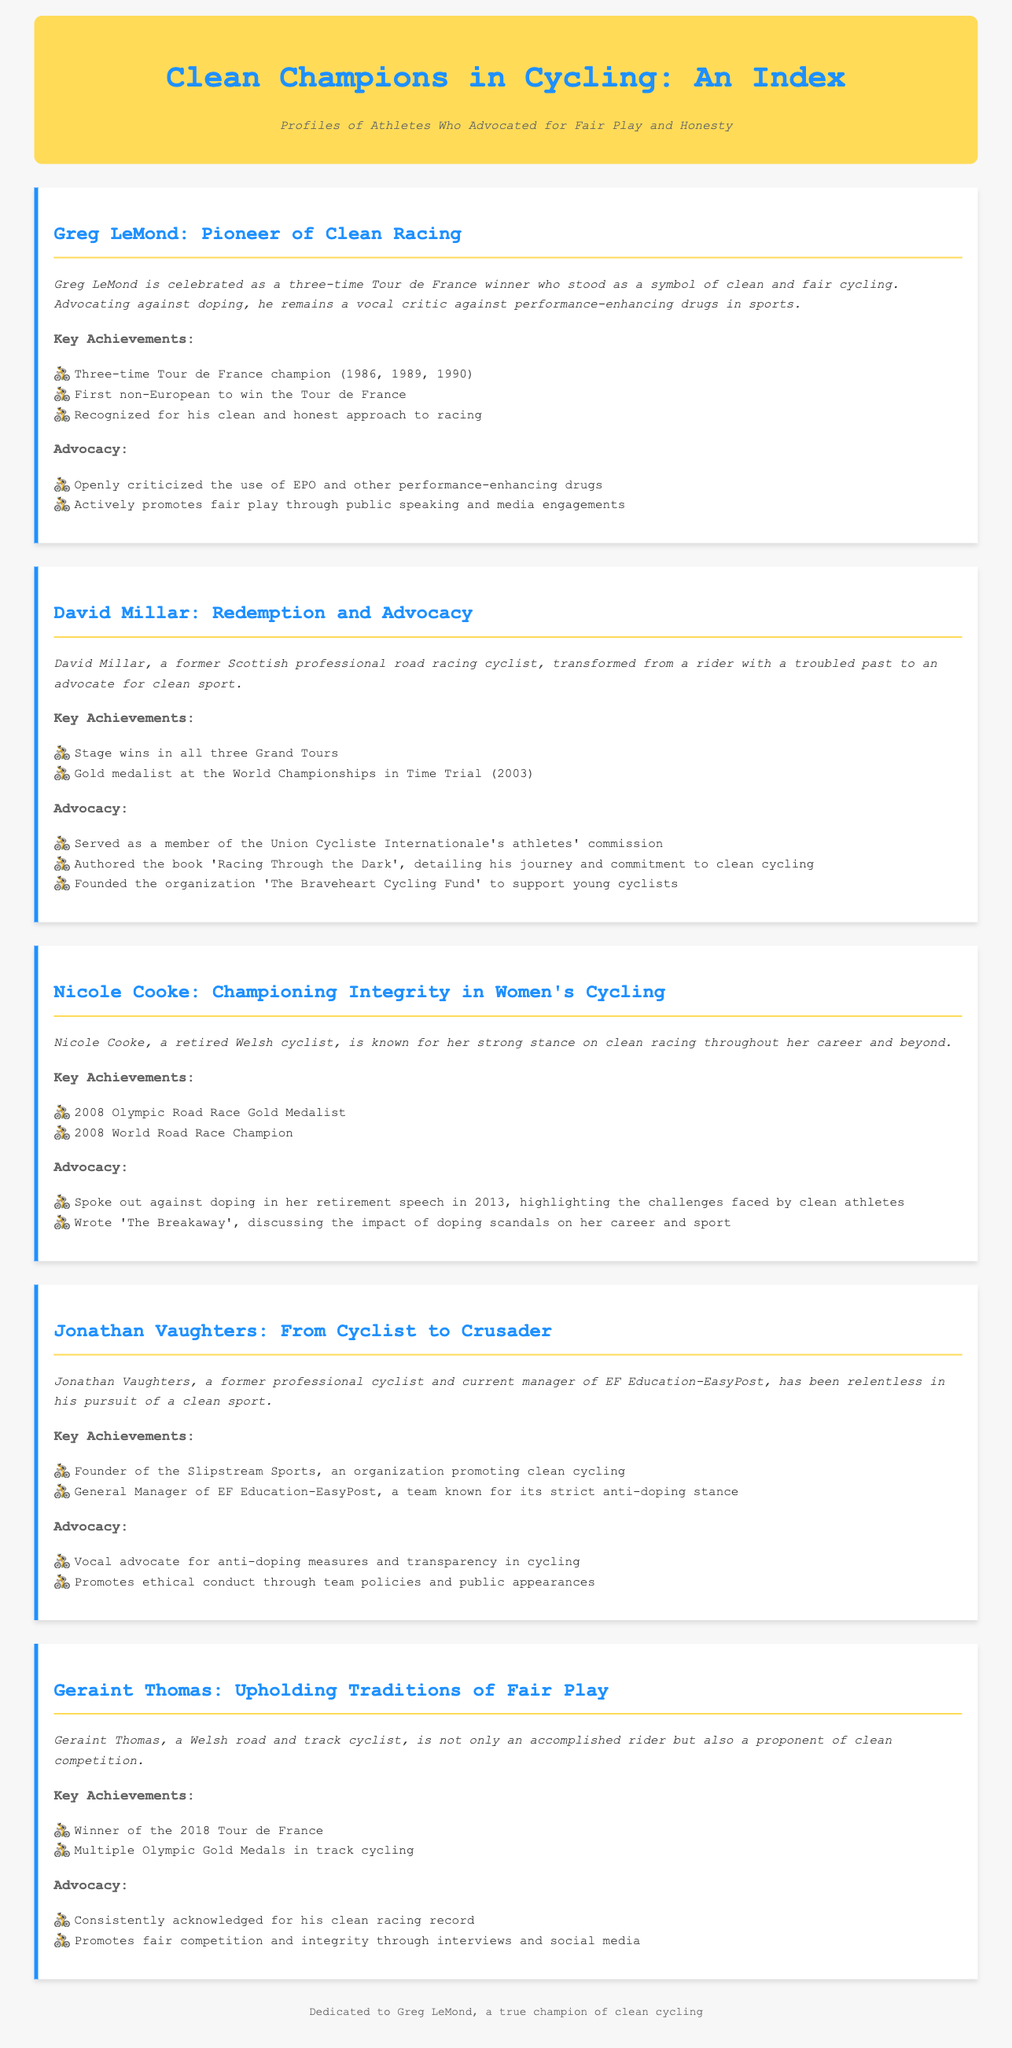What year did Greg LeMond win his first Tour de France? The document states that Greg LeMond won his first Tour de France in 1986.
Answer: 1986 How many Olympic Gold Medals has Geraint Thomas won? According to the document, Geraint Thomas has won multiple Olympic Gold Medals in track cycling.
Answer: Multiple What is the title of the book authored by David Millar? The document mentions that David Millar authored the book titled 'Racing Through the Dark'.
Answer: Racing Through the Dark Which champion founded The Braveheart Cycling Fund? The document specifies that David Millar founded The Braveheart Cycling Fund.
Answer: David Millar Who is recognized for being the first non-European to win the Tour de France? The document attributes the recognition of the first non-European to win the Tour de France to Greg LeMond.
Answer: Greg LeMond What role does Jonathan Vaughters currently hold? The document states that Jonathan Vaughters is the General Manager of EF Education-EasyPost.
Answer: General Manager of EF Education-EasyPost In what year did Nicole Cooke win the Olympic Road Race Gold Medal? The document notes that Nicole Cooke won the Olympic Road Race Gold Medal in 2008.
Answer: 2008 Which athlete publicly criticized the use of EPO? The document indicates that Greg LeMond openly criticized the use of EPO.
Answer: Greg LeMond What is the primary focus of the profiles in this document? The document outlines that the profiles focus on athletes who advocated for fair play and honesty in cycling.
Answer: Fair play and honesty 